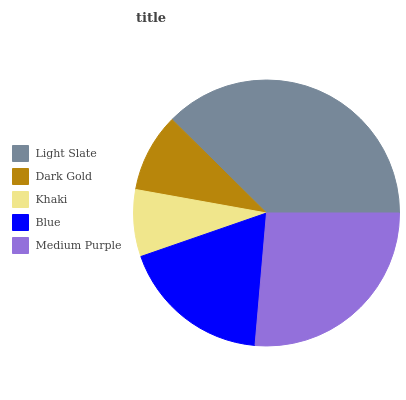Is Khaki the minimum?
Answer yes or no. Yes. Is Light Slate the maximum?
Answer yes or no. Yes. Is Dark Gold the minimum?
Answer yes or no. No. Is Dark Gold the maximum?
Answer yes or no. No. Is Light Slate greater than Dark Gold?
Answer yes or no. Yes. Is Dark Gold less than Light Slate?
Answer yes or no. Yes. Is Dark Gold greater than Light Slate?
Answer yes or no. No. Is Light Slate less than Dark Gold?
Answer yes or no. No. Is Blue the high median?
Answer yes or no. Yes. Is Blue the low median?
Answer yes or no. Yes. Is Medium Purple the high median?
Answer yes or no. No. Is Khaki the low median?
Answer yes or no. No. 